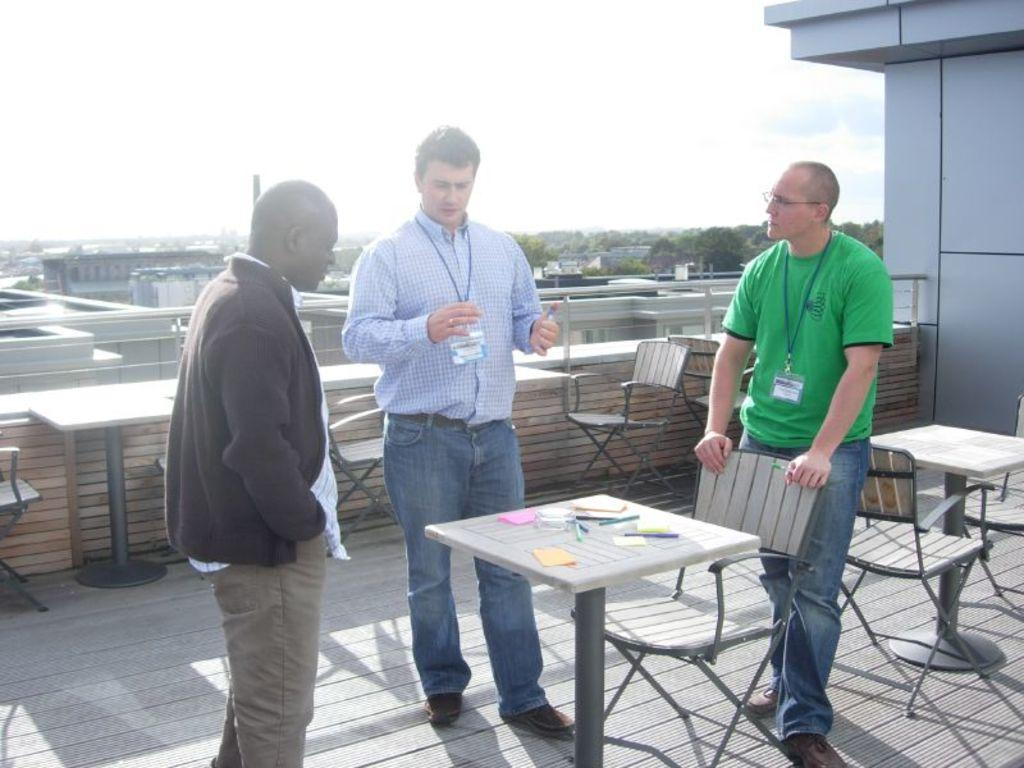How many men are present in the image? There are three men standing in the image. What are the men wearing that is visible in the image? The men are wearing badges. Is there anyone else in the image besides the three men? Yes, there is a man standing in front of the three men. What furniture can be seen in the image? There is a table and a chair in the image. What can be seen in the background of the image? Trees, the sky, and a building are visible in the background of the image. What type of ring can be seen on the farmer's finger in the image? There is no farmer present in the image, and therefore no ring can be seen on their finger. 